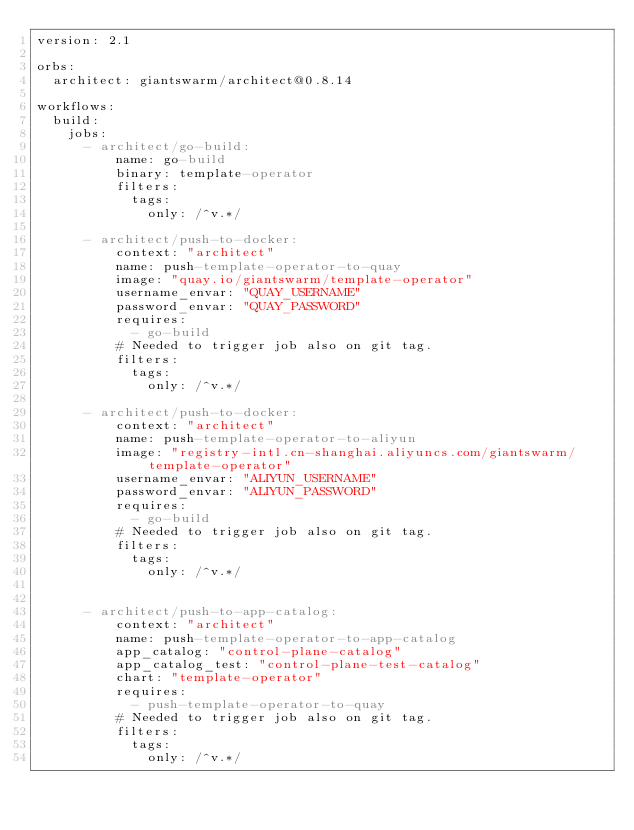Convert code to text. <code><loc_0><loc_0><loc_500><loc_500><_YAML_>version: 2.1

orbs:
  architect: giantswarm/architect@0.8.14

workflows:
  build:
    jobs:
      - architect/go-build:
          name: go-build
          binary: template-operator
          filters:
            tags:
              only: /^v.*/

      - architect/push-to-docker:
          context: "architect"
          name: push-template-operator-to-quay
          image: "quay.io/giantswarm/template-operator"
          username_envar: "QUAY_USERNAME"
          password_envar: "QUAY_PASSWORD"
          requires:
            - go-build
          # Needed to trigger job also on git tag.
          filters:
            tags:
              only: /^v.*/

      - architect/push-to-docker:
          context: "architect"
          name: push-template-operator-to-aliyun
          image: "registry-intl.cn-shanghai.aliyuncs.com/giantswarm/template-operator"
          username_envar: "ALIYUN_USERNAME"
          password_envar: "ALIYUN_PASSWORD"
          requires:
            - go-build
          # Needed to trigger job also on git tag.
          filters:
            tags:
              only: /^v.*/


      - architect/push-to-app-catalog:
          context: "architect"
          name: push-template-operator-to-app-catalog
          app_catalog: "control-plane-catalog"
          app_catalog_test: "control-plane-test-catalog"
          chart: "template-operator"
          requires:
            - push-template-operator-to-quay
          # Needed to trigger job also on git tag.
          filters:
            tags:
              only: /^v.*/
</code> 